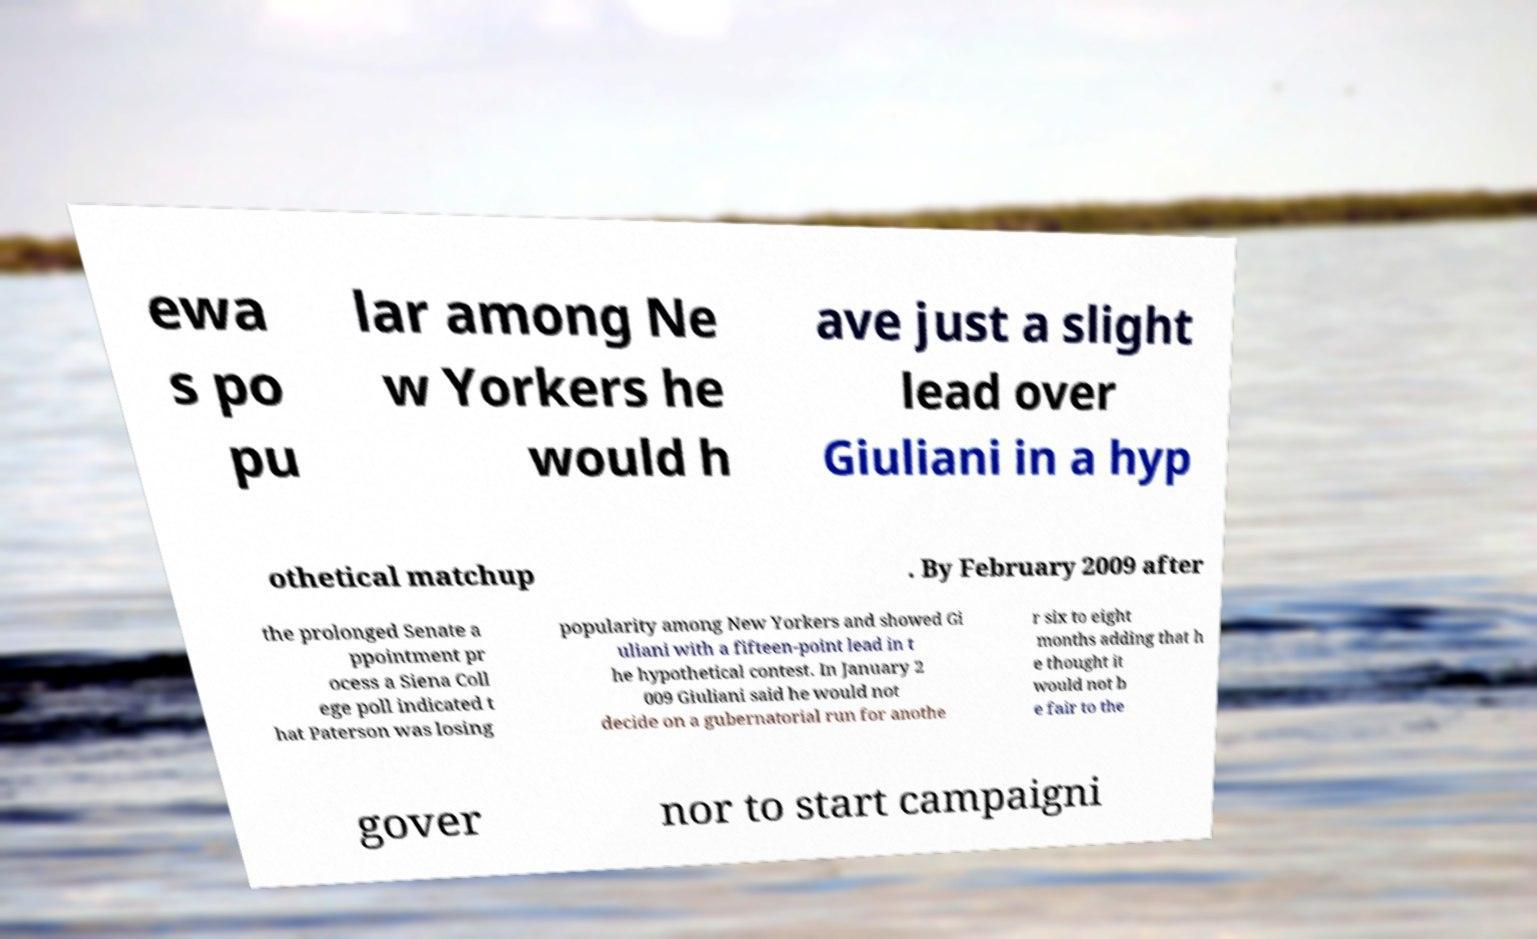Could you assist in decoding the text presented in this image and type it out clearly? ewa s po pu lar among Ne w Yorkers he would h ave just a slight lead over Giuliani in a hyp othetical matchup . By February 2009 after the prolonged Senate a ppointment pr ocess a Siena Coll ege poll indicated t hat Paterson was losing popularity among New Yorkers and showed Gi uliani with a fifteen-point lead in t he hypothetical contest. In January 2 009 Giuliani said he would not decide on a gubernatorial run for anothe r six to eight months adding that h e thought it would not b e fair to the gover nor to start campaigni 